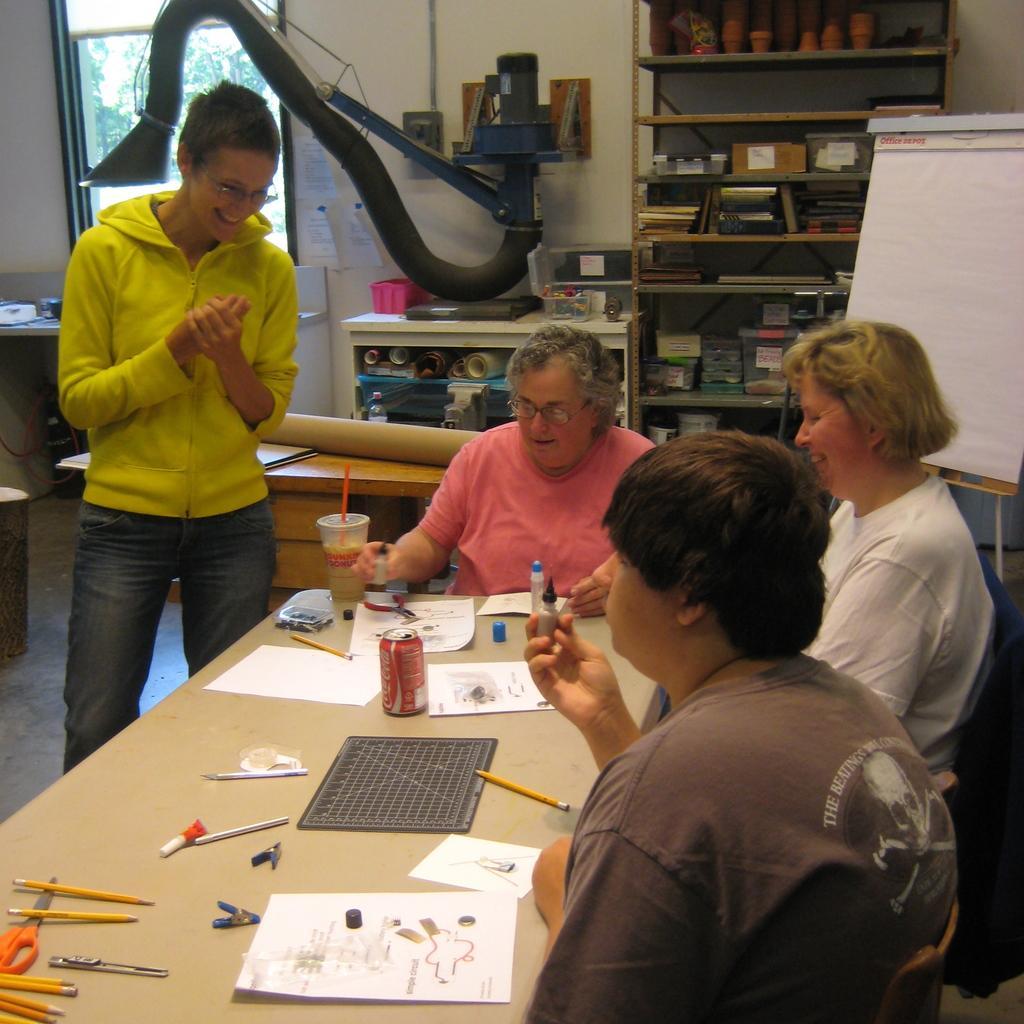How would you summarize this image in a sentence or two? In this picture we can see three persons sitting on the chairs around the table. And one person is standing here. And on the table there is a paper, a tin, and a glass. And on the background there is a rack. This is the wall and this is the floor. 